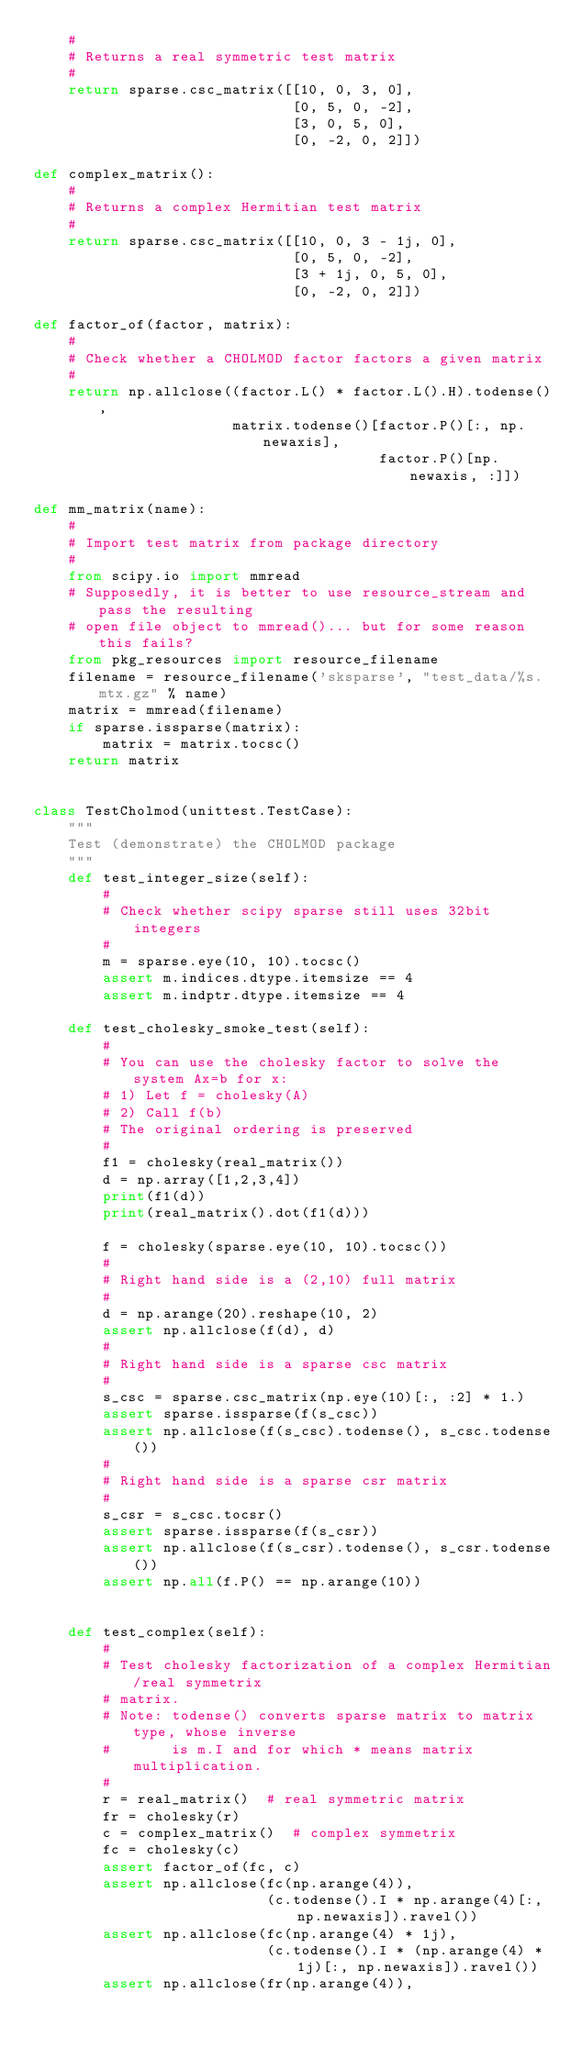Convert code to text. <code><loc_0><loc_0><loc_500><loc_500><_Python_>    #
    # Returns a real symmetric test matrix
    #
    return sparse.csc_matrix([[10, 0, 3, 0],
                              [0, 5, 0, -2],
                              [3, 0, 5, 0],
                              [0, -2, 0, 2]])

def complex_matrix():
    #
    # Returns a complex Hermitian test matrix
    # 
    return sparse.csc_matrix([[10, 0, 3 - 1j, 0],
                              [0, 5, 0, -2],
                              [3 + 1j, 0, 5, 0],
                              [0, -2, 0, 2]])
        
def factor_of(factor, matrix):
    #
    # Check whether a CHOLMOD factor factors a given matrix
    #
    return np.allclose((factor.L() * factor.L().H).todense(),
                       matrix.todense()[factor.P()[:, np.newaxis],
                                        factor.P()[np.newaxis, :]])
    
def mm_matrix(name):
    #
    # Import test matrix from package directory
    #
    from scipy.io import mmread
    # Supposedly, it is better to use resource_stream and pass the resulting
    # open file object to mmread()... but for some reason this fails?
    from pkg_resources import resource_filename
    filename = resource_filename('sksparse', "test_data/%s.mtx.gz" % name)
    matrix = mmread(filename)
    if sparse.issparse(matrix):
        matrix = matrix.tocsc()
    return matrix

    
class TestCholmod(unittest.TestCase):
    """
    Test (demonstrate) the CHOLMOD package
    """
    def test_integer_size(self):
        #
        # Check whether scipy sparse still uses 32bit integers
        # 
        m = sparse.eye(10, 10).tocsc()
        assert m.indices.dtype.itemsize == 4
        assert m.indptr.dtype.itemsize == 4
    
    def test_cholesky_smoke_test(self):
        #
        # You can use the cholesky factor to solve the system Ax=b for x: 
        # 1) Let f = cholesky(A)
        # 2) Call f(b)
        # The original ordering is preserved 
        #
        f1 = cholesky(real_matrix())
        d = np.array([1,2,3,4])
        print(f1(d))
        print(real_matrix().dot(f1(d)))
        
        f = cholesky(sparse.eye(10, 10).tocsc())
        #
        # Right hand side is a (2,10) full matrix
        # 
        d = np.arange(20).reshape(10, 2)
        assert np.allclose(f(d), d)
        #
        # Right hand side is a sparse csc matrix
        # 
        s_csc = sparse.csc_matrix(np.eye(10)[:, :2] * 1.)
        assert sparse.issparse(f(s_csc))
        assert np.allclose(f(s_csc).todense(), s_csc.todense())
        #
        # Right hand side is a sparse csr matrix
        # 
        s_csr = s_csc.tocsr()
        assert sparse.issparse(f(s_csr))
        assert np.allclose(f(s_csr).todense(), s_csr.todense())
        assert np.all(f.P() == np.arange(10))
    
    
    def test_complex(self):
        #
        # Test cholesky factorization of a complex Hermitian/real symmetrix 
        # matrix.
        # Note: todense() converts sparse matrix to matrix type, whose inverse
        #       is m.I and for which * means matrix multiplication.
        # 
        r = real_matrix()  # real symmetric matrix
        fr = cholesky(r)   
        c = complex_matrix()  # complex symmetrix
        fc = cholesky(c)
        assert factor_of(fc, c)
        assert np.allclose(fc(np.arange(4)),
                           (c.todense().I * np.arange(4)[:, np.newaxis]).ravel())
        assert np.allclose(fc(np.arange(4) * 1j),
                           (c.todense().I * (np.arange(4) * 1j)[:, np.newaxis]).ravel())
        assert np.allclose(fr(np.arange(4)),</code> 